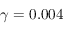Convert formula to latex. <formula><loc_0><loc_0><loc_500><loc_500>\gamma = 0 . 0 0 4</formula> 